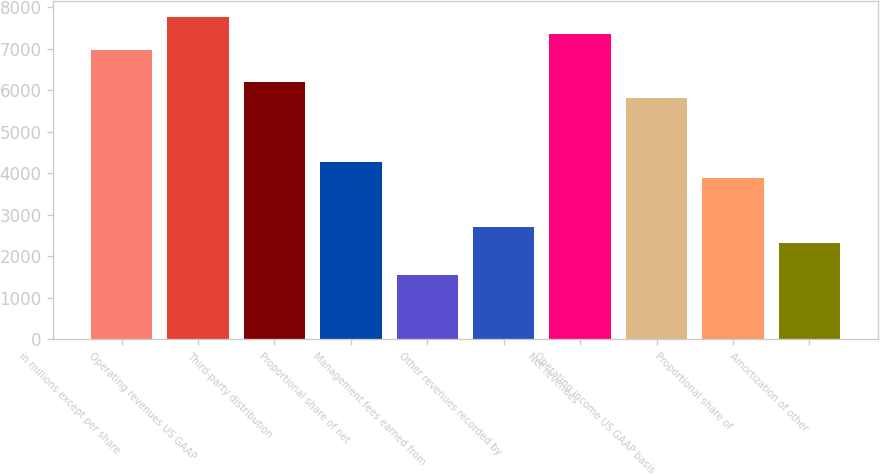Convert chart to OTSL. <chart><loc_0><loc_0><loc_500><loc_500><bar_chart><fcel>in millions except per share<fcel>Operating revenues US GAAP<fcel>Third-party distribution<fcel>Proportional share of net<fcel>Management fees earned from<fcel>Other revenues recorded by<fcel>Net revenues<fcel>Operating income US GAAP basis<fcel>Proportional share of<fcel>Amortization of other<nl><fcel>6980.78<fcel>7756.24<fcel>6205.32<fcel>4266.67<fcel>1552.56<fcel>2715.75<fcel>7368.51<fcel>5817.59<fcel>3878.94<fcel>2328.02<nl></chart> 